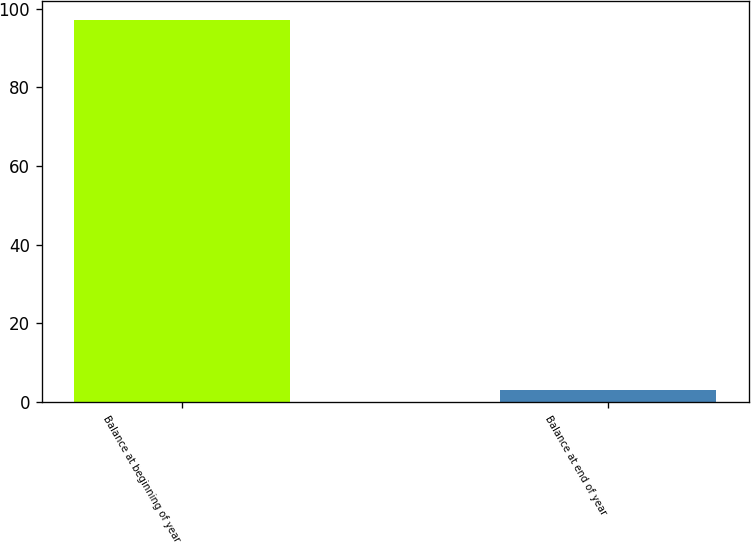<chart> <loc_0><loc_0><loc_500><loc_500><bar_chart><fcel>Balance at beginning of year<fcel>Balance at end of year<nl><fcel>97<fcel>3<nl></chart> 